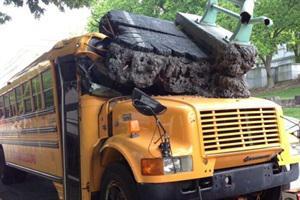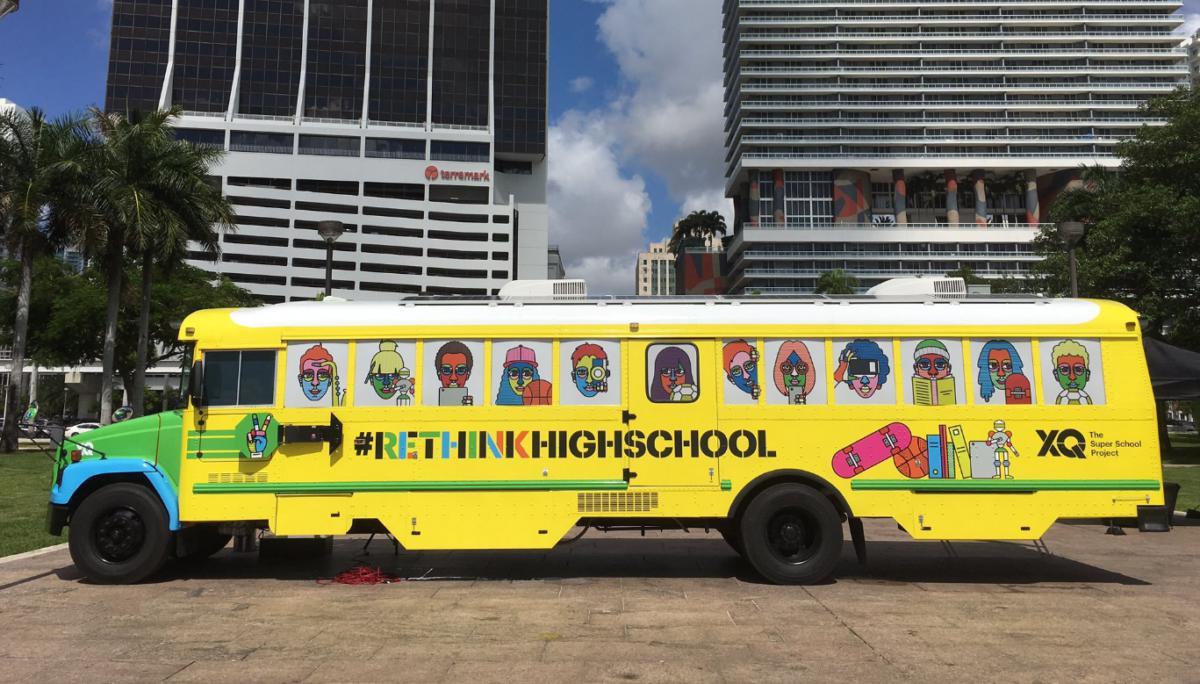The first image is the image on the left, the second image is the image on the right. For the images shown, is this caption "In one image there is a single schoolbus that has been involved in an accident and is wrecked in the center of the image." true? Answer yes or no. Yes. The first image is the image on the left, the second image is the image on the right. Assess this claim about the two images: "One image shows a bus decorated with some type of 'artwork', and the other image shows a bus with severe impact damage on its front end.". Correct or not? Answer yes or no. Yes. 